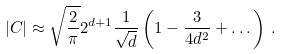<formula> <loc_0><loc_0><loc_500><loc_500>| C | \approx \sqrt { \frac { 2 } { \pi } } 2 ^ { d + 1 } \frac { 1 } { \sqrt { d } } \left ( 1 - \frac { 3 } { 4 d ^ { 2 } } + \dots \right ) \, .</formula> 